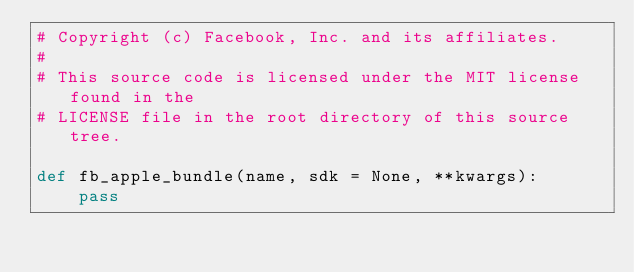<code> <loc_0><loc_0><loc_500><loc_500><_Python_># Copyright (c) Facebook, Inc. and its affiliates.
#
# This source code is licensed under the MIT license found in the
# LICENSE file in the root directory of this source tree.

def fb_apple_bundle(name, sdk = None, **kwargs):
    pass
</code> 